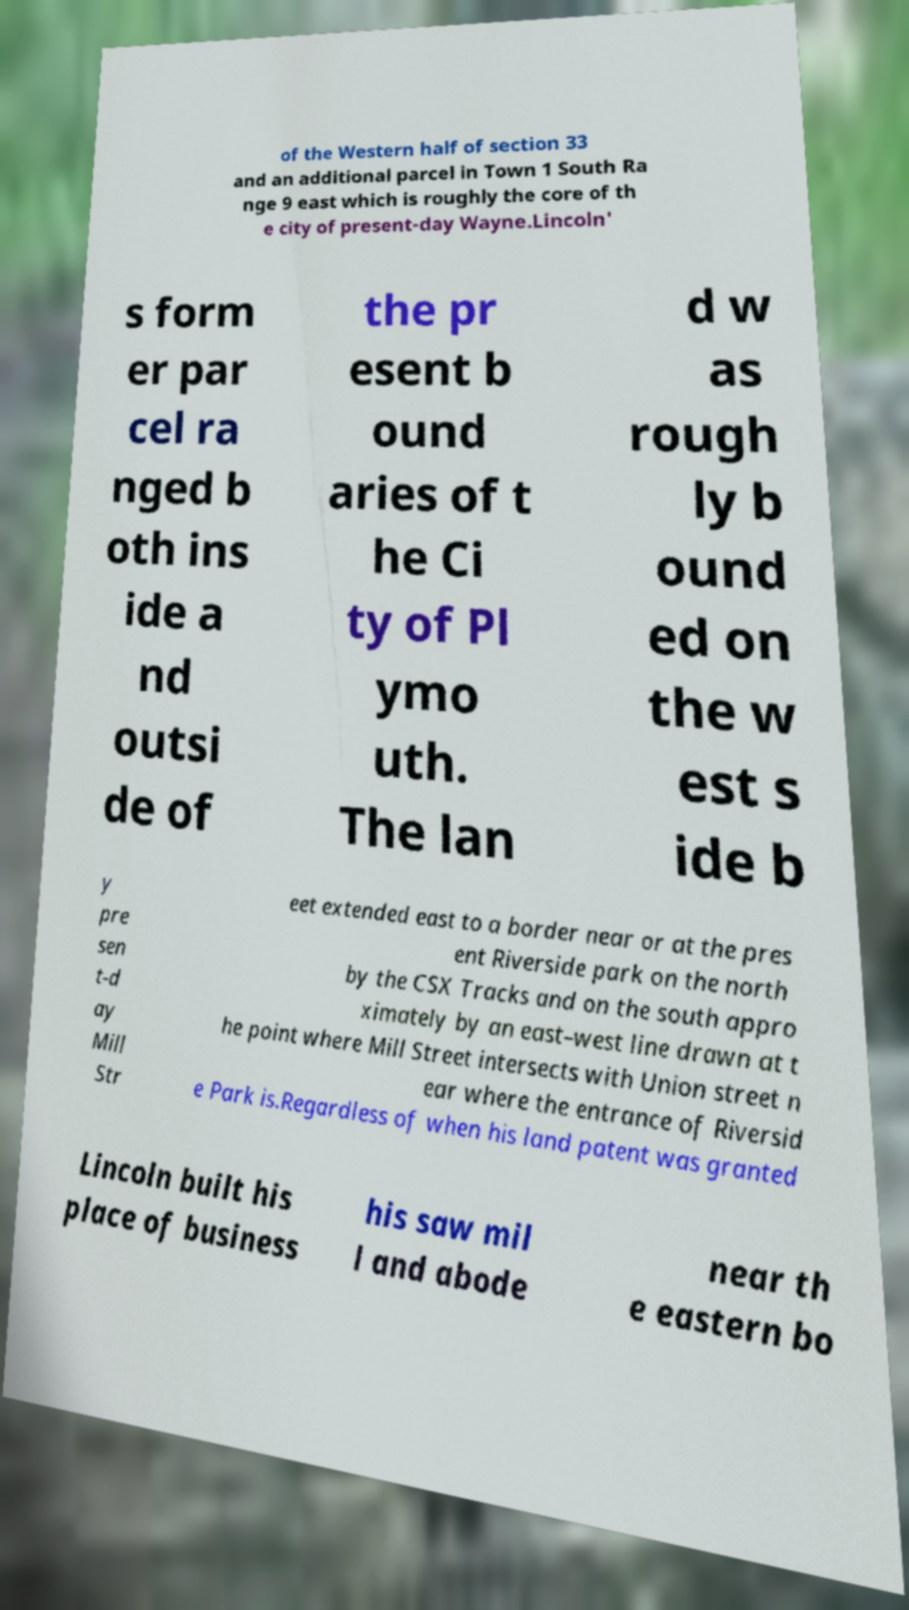Can you read and provide the text displayed in the image?This photo seems to have some interesting text. Can you extract and type it out for me? of the Western half of section 33 and an additional parcel in Town 1 South Ra nge 9 east which is roughly the core of th e city of present-day Wayne.Lincoln' s form er par cel ra nged b oth ins ide a nd outsi de of the pr esent b ound aries of t he Ci ty of Pl ymo uth. The lan d w as rough ly b ound ed on the w est s ide b y pre sen t-d ay Mill Str eet extended east to a border near or at the pres ent Riverside park on the north by the CSX Tracks and on the south appro ximately by an east–west line drawn at t he point where Mill Street intersects with Union street n ear where the entrance of Riversid e Park is.Regardless of when his land patent was granted Lincoln built his place of business his saw mil l and abode near th e eastern bo 